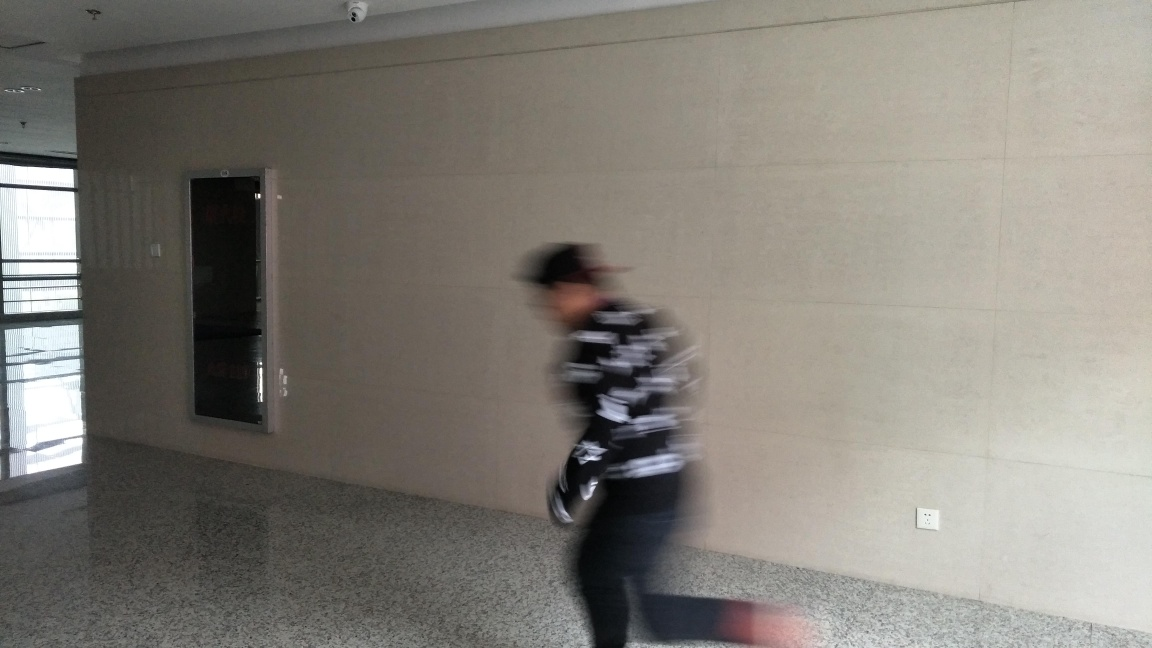Why might the person in the image be blurred? The motion blur effect suggests that the person is moving quickly through the frame, possibly walking or running. The blur captures the energy and haste of the moment. The photograph's exposure time may have been too long to freeze the action sharply, or this could be a stylistic choice to emphasize movement. 